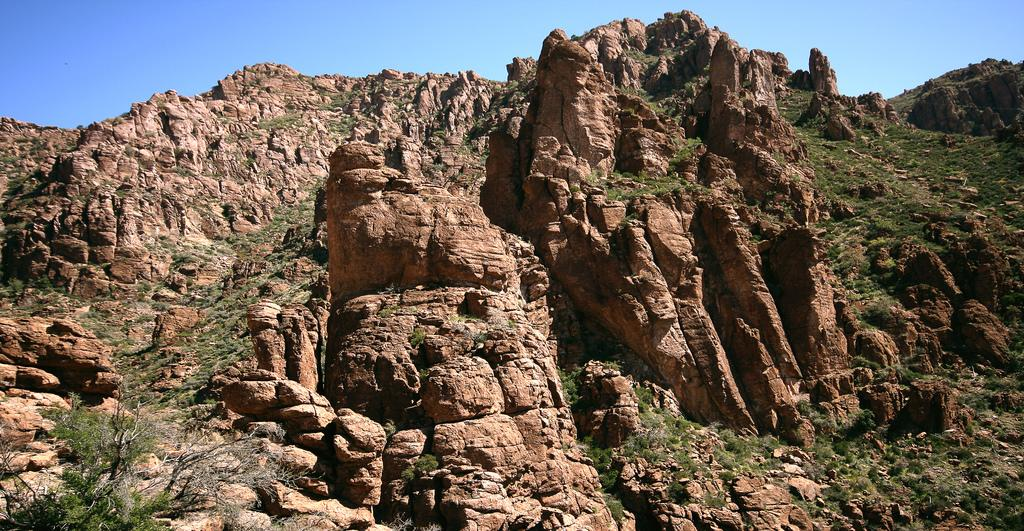What type of natural elements can be seen in the image? There are rocks and grass visible in the image. What is visible in the background of the image? The sky is visible in the background of the image. Can you see anyone kicking a soccer ball in the image? There is no soccer ball or person kicking it present in the image. What type of architectural structure can be seen in the image? There is no architectural structure mentioned in the provided facts; the image only features rocks, grass, and the sky. 